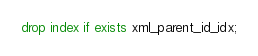Convert code to text. <code><loc_0><loc_0><loc_500><loc_500><_SQL_>drop index if exists xml_parent_id_idx;
</code> 